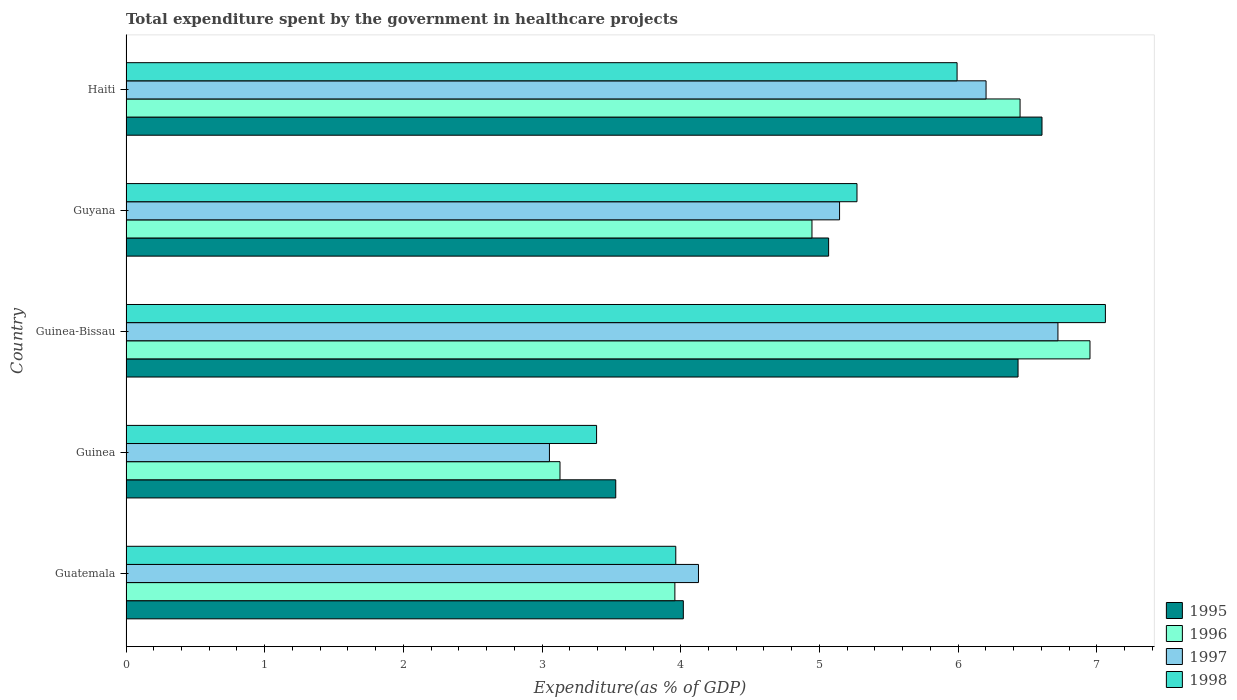How many different coloured bars are there?
Offer a terse response. 4. How many bars are there on the 4th tick from the bottom?
Make the answer very short. 4. What is the label of the 3rd group of bars from the top?
Give a very brief answer. Guinea-Bissau. What is the total expenditure spent by the government in healthcare projects in 1996 in Guinea-Bissau?
Provide a short and direct response. 6.95. Across all countries, what is the maximum total expenditure spent by the government in healthcare projects in 1995?
Ensure brevity in your answer.  6.6. Across all countries, what is the minimum total expenditure spent by the government in healthcare projects in 1997?
Ensure brevity in your answer.  3.05. In which country was the total expenditure spent by the government in healthcare projects in 1998 maximum?
Your answer should be compact. Guinea-Bissau. In which country was the total expenditure spent by the government in healthcare projects in 1995 minimum?
Ensure brevity in your answer.  Guinea. What is the total total expenditure spent by the government in healthcare projects in 1998 in the graph?
Make the answer very short. 25.68. What is the difference between the total expenditure spent by the government in healthcare projects in 1996 in Guyana and that in Haiti?
Make the answer very short. -1.5. What is the difference between the total expenditure spent by the government in healthcare projects in 1996 in Guinea-Bissau and the total expenditure spent by the government in healthcare projects in 1997 in Guatemala?
Give a very brief answer. 2.82. What is the average total expenditure spent by the government in healthcare projects in 1995 per country?
Your answer should be compact. 5.13. What is the difference between the total expenditure spent by the government in healthcare projects in 1995 and total expenditure spent by the government in healthcare projects in 1997 in Guinea-Bissau?
Keep it short and to the point. -0.29. In how many countries, is the total expenditure spent by the government in healthcare projects in 1997 greater than 0.2 %?
Ensure brevity in your answer.  5. What is the ratio of the total expenditure spent by the government in healthcare projects in 1996 in Guatemala to that in Guyana?
Your response must be concise. 0.8. Is the total expenditure spent by the government in healthcare projects in 1995 in Guinea-Bissau less than that in Guyana?
Offer a terse response. No. Is the difference between the total expenditure spent by the government in healthcare projects in 1995 in Guinea and Haiti greater than the difference between the total expenditure spent by the government in healthcare projects in 1997 in Guinea and Haiti?
Your answer should be very brief. Yes. What is the difference between the highest and the second highest total expenditure spent by the government in healthcare projects in 1997?
Give a very brief answer. 0.52. What is the difference between the highest and the lowest total expenditure spent by the government in healthcare projects in 1996?
Your answer should be compact. 3.82. In how many countries, is the total expenditure spent by the government in healthcare projects in 1997 greater than the average total expenditure spent by the government in healthcare projects in 1997 taken over all countries?
Your response must be concise. 3. Is the sum of the total expenditure spent by the government in healthcare projects in 1995 in Guatemala and Guinea-Bissau greater than the maximum total expenditure spent by the government in healthcare projects in 1997 across all countries?
Provide a short and direct response. Yes. What does the 2nd bar from the top in Guinea-Bissau represents?
Provide a succinct answer. 1997. What does the 1st bar from the bottom in Guinea represents?
Provide a succinct answer. 1995. Is it the case that in every country, the sum of the total expenditure spent by the government in healthcare projects in 1996 and total expenditure spent by the government in healthcare projects in 1997 is greater than the total expenditure spent by the government in healthcare projects in 1998?
Your response must be concise. Yes. What is the difference between two consecutive major ticks on the X-axis?
Provide a succinct answer. 1. Are the values on the major ticks of X-axis written in scientific E-notation?
Ensure brevity in your answer.  No. Does the graph contain any zero values?
Your answer should be compact. No. How are the legend labels stacked?
Offer a terse response. Vertical. What is the title of the graph?
Give a very brief answer. Total expenditure spent by the government in healthcare projects. Does "2007" appear as one of the legend labels in the graph?
Keep it short and to the point. No. What is the label or title of the X-axis?
Keep it short and to the point. Expenditure(as % of GDP). What is the Expenditure(as % of GDP) of 1995 in Guatemala?
Your answer should be compact. 4.02. What is the Expenditure(as % of GDP) of 1996 in Guatemala?
Ensure brevity in your answer.  3.96. What is the Expenditure(as % of GDP) of 1997 in Guatemala?
Your answer should be compact. 4.13. What is the Expenditure(as % of GDP) in 1998 in Guatemala?
Give a very brief answer. 3.96. What is the Expenditure(as % of GDP) of 1995 in Guinea?
Ensure brevity in your answer.  3.53. What is the Expenditure(as % of GDP) in 1996 in Guinea?
Your response must be concise. 3.13. What is the Expenditure(as % of GDP) of 1997 in Guinea?
Provide a short and direct response. 3.05. What is the Expenditure(as % of GDP) in 1998 in Guinea?
Provide a succinct answer. 3.39. What is the Expenditure(as % of GDP) in 1995 in Guinea-Bissau?
Provide a short and direct response. 6.43. What is the Expenditure(as % of GDP) of 1996 in Guinea-Bissau?
Provide a short and direct response. 6.95. What is the Expenditure(as % of GDP) of 1997 in Guinea-Bissau?
Give a very brief answer. 6.72. What is the Expenditure(as % of GDP) in 1998 in Guinea-Bissau?
Your answer should be very brief. 7.06. What is the Expenditure(as % of GDP) in 1995 in Guyana?
Offer a very short reply. 5.07. What is the Expenditure(as % of GDP) of 1996 in Guyana?
Ensure brevity in your answer.  4.95. What is the Expenditure(as % of GDP) in 1997 in Guyana?
Ensure brevity in your answer.  5.15. What is the Expenditure(as % of GDP) of 1998 in Guyana?
Keep it short and to the point. 5.27. What is the Expenditure(as % of GDP) in 1995 in Haiti?
Provide a succinct answer. 6.6. What is the Expenditure(as % of GDP) of 1996 in Haiti?
Provide a succinct answer. 6.45. What is the Expenditure(as % of GDP) of 1997 in Haiti?
Your answer should be very brief. 6.2. What is the Expenditure(as % of GDP) in 1998 in Haiti?
Your answer should be compact. 5.99. Across all countries, what is the maximum Expenditure(as % of GDP) of 1995?
Your response must be concise. 6.6. Across all countries, what is the maximum Expenditure(as % of GDP) of 1996?
Make the answer very short. 6.95. Across all countries, what is the maximum Expenditure(as % of GDP) of 1997?
Offer a terse response. 6.72. Across all countries, what is the maximum Expenditure(as % of GDP) of 1998?
Your answer should be very brief. 7.06. Across all countries, what is the minimum Expenditure(as % of GDP) of 1995?
Your answer should be very brief. 3.53. Across all countries, what is the minimum Expenditure(as % of GDP) of 1996?
Your answer should be compact. 3.13. Across all countries, what is the minimum Expenditure(as % of GDP) of 1997?
Offer a terse response. 3.05. Across all countries, what is the minimum Expenditure(as % of GDP) of 1998?
Your answer should be compact. 3.39. What is the total Expenditure(as % of GDP) in 1995 in the graph?
Ensure brevity in your answer.  25.65. What is the total Expenditure(as % of GDP) of 1996 in the graph?
Offer a very short reply. 25.43. What is the total Expenditure(as % of GDP) in 1997 in the graph?
Your response must be concise. 25.25. What is the total Expenditure(as % of GDP) of 1998 in the graph?
Your answer should be very brief. 25.68. What is the difference between the Expenditure(as % of GDP) of 1995 in Guatemala and that in Guinea?
Ensure brevity in your answer.  0.49. What is the difference between the Expenditure(as % of GDP) of 1996 in Guatemala and that in Guinea?
Keep it short and to the point. 0.83. What is the difference between the Expenditure(as % of GDP) in 1997 in Guatemala and that in Guinea?
Your response must be concise. 1.07. What is the difference between the Expenditure(as % of GDP) of 1998 in Guatemala and that in Guinea?
Make the answer very short. 0.57. What is the difference between the Expenditure(as % of GDP) of 1995 in Guatemala and that in Guinea-Bissau?
Offer a very short reply. -2.41. What is the difference between the Expenditure(as % of GDP) of 1996 in Guatemala and that in Guinea-Bissau?
Ensure brevity in your answer.  -2.99. What is the difference between the Expenditure(as % of GDP) in 1997 in Guatemala and that in Guinea-Bissau?
Provide a succinct answer. -2.59. What is the difference between the Expenditure(as % of GDP) in 1998 in Guatemala and that in Guinea-Bissau?
Offer a very short reply. -3.1. What is the difference between the Expenditure(as % of GDP) of 1995 in Guatemala and that in Guyana?
Ensure brevity in your answer.  -1.05. What is the difference between the Expenditure(as % of GDP) in 1996 in Guatemala and that in Guyana?
Your answer should be very brief. -0.99. What is the difference between the Expenditure(as % of GDP) in 1997 in Guatemala and that in Guyana?
Keep it short and to the point. -1.02. What is the difference between the Expenditure(as % of GDP) in 1998 in Guatemala and that in Guyana?
Your answer should be very brief. -1.31. What is the difference between the Expenditure(as % of GDP) in 1995 in Guatemala and that in Haiti?
Keep it short and to the point. -2.59. What is the difference between the Expenditure(as % of GDP) of 1996 in Guatemala and that in Haiti?
Keep it short and to the point. -2.49. What is the difference between the Expenditure(as % of GDP) of 1997 in Guatemala and that in Haiti?
Ensure brevity in your answer.  -2.07. What is the difference between the Expenditure(as % of GDP) in 1998 in Guatemala and that in Haiti?
Keep it short and to the point. -2.03. What is the difference between the Expenditure(as % of GDP) of 1995 in Guinea and that in Guinea-Bissau?
Your answer should be compact. -2.9. What is the difference between the Expenditure(as % of GDP) in 1996 in Guinea and that in Guinea-Bissau?
Make the answer very short. -3.82. What is the difference between the Expenditure(as % of GDP) of 1997 in Guinea and that in Guinea-Bissau?
Your answer should be compact. -3.67. What is the difference between the Expenditure(as % of GDP) of 1998 in Guinea and that in Guinea-Bissau?
Provide a short and direct response. -3.67. What is the difference between the Expenditure(as % of GDP) in 1995 in Guinea and that in Guyana?
Make the answer very short. -1.53. What is the difference between the Expenditure(as % of GDP) in 1996 in Guinea and that in Guyana?
Your answer should be very brief. -1.82. What is the difference between the Expenditure(as % of GDP) of 1997 in Guinea and that in Guyana?
Offer a very short reply. -2.09. What is the difference between the Expenditure(as % of GDP) of 1998 in Guinea and that in Guyana?
Give a very brief answer. -1.88. What is the difference between the Expenditure(as % of GDP) in 1995 in Guinea and that in Haiti?
Provide a short and direct response. -3.07. What is the difference between the Expenditure(as % of GDP) in 1996 in Guinea and that in Haiti?
Make the answer very short. -3.32. What is the difference between the Expenditure(as % of GDP) of 1997 in Guinea and that in Haiti?
Provide a short and direct response. -3.15. What is the difference between the Expenditure(as % of GDP) in 1998 in Guinea and that in Haiti?
Your answer should be compact. -2.6. What is the difference between the Expenditure(as % of GDP) in 1995 in Guinea-Bissau and that in Guyana?
Ensure brevity in your answer.  1.37. What is the difference between the Expenditure(as % of GDP) in 1996 in Guinea-Bissau and that in Guyana?
Make the answer very short. 2. What is the difference between the Expenditure(as % of GDP) of 1997 in Guinea-Bissau and that in Guyana?
Keep it short and to the point. 1.57. What is the difference between the Expenditure(as % of GDP) in 1998 in Guinea-Bissau and that in Guyana?
Give a very brief answer. 1.79. What is the difference between the Expenditure(as % of GDP) in 1995 in Guinea-Bissau and that in Haiti?
Your answer should be compact. -0.17. What is the difference between the Expenditure(as % of GDP) in 1996 in Guinea-Bissau and that in Haiti?
Make the answer very short. 0.5. What is the difference between the Expenditure(as % of GDP) in 1997 in Guinea-Bissau and that in Haiti?
Your answer should be compact. 0.52. What is the difference between the Expenditure(as % of GDP) of 1998 in Guinea-Bissau and that in Haiti?
Provide a short and direct response. 1.07. What is the difference between the Expenditure(as % of GDP) in 1995 in Guyana and that in Haiti?
Give a very brief answer. -1.54. What is the difference between the Expenditure(as % of GDP) in 1996 in Guyana and that in Haiti?
Your answer should be compact. -1.5. What is the difference between the Expenditure(as % of GDP) of 1997 in Guyana and that in Haiti?
Offer a terse response. -1.06. What is the difference between the Expenditure(as % of GDP) of 1998 in Guyana and that in Haiti?
Make the answer very short. -0.72. What is the difference between the Expenditure(as % of GDP) of 1995 in Guatemala and the Expenditure(as % of GDP) of 1996 in Guinea?
Provide a short and direct response. 0.89. What is the difference between the Expenditure(as % of GDP) in 1995 in Guatemala and the Expenditure(as % of GDP) in 1997 in Guinea?
Your answer should be very brief. 0.97. What is the difference between the Expenditure(as % of GDP) in 1995 in Guatemala and the Expenditure(as % of GDP) in 1998 in Guinea?
Provide a short and direct response. 0.63. What is the difference between the Expenditure(as % of GDP) of 1996 in Guatemala and the Expenditure(as % of GDP) of 1997 in Guinea?
Keep it short and to the point. 0.9. What is the difference between the Expenditure(as % of GDP) of 1996 in Guatemala and the Expenditure(as % of GDP) of 1998 in Guinea?
Your response must be concise. 0.56. What is the difference between the Expenditure(as % of GDP) in 1997 in Guatemala and the Expenditure(as % of GDP) in 1998 in Guinea?
Your answer should be compact. 0.73. What is the difference between the Expenditure(as % of GDP) in 1995 in Guatemala and the Expenditure(as % of GDP) in 1996 in Guinea-Bissau?
Your response must be concise. -2.93. What is the difference between the Expenditure(as % of GDP) in 1995 in Guatemala and the Expenditure(as % of GDP) in 1997 in Guinea-Bissau?
Offer a terse response. -2.7. What is the difference between the Expenditure(as % of GDP) in 1995 in Guatemala and the Expenditure(as % of GDP) in 1998 in Guinea-Bissau?
Your answer should be compact. -3.04. What is the difference between the Expenditure(as % of GDP) of 1996 in Guatemala and the Expenditure(as % of GDP) of 1997 in Guinea-Bissau?
Give a very brief answer. -2.76. What is the difference between the Expenditure(as % of GDP) of 1996 in Guatemala and the Expenditure(as % of GDP) of 1998 in Guinea-Bissau?
Your answer should be compact. -3.1. What is the difference between the Expenditure(as % of GDP) in 1997 in Guatemala and the Expenditure(as % of GDP) in 1998 in Guinea-Bissau?
Your answer should be compact. -2.93. What is the difference between the Expenditure(as % of GDP) in 1995 in Guatemala and the Expenditure(as % of GDP) in 1996 in Guyana?
Your answer should be compact. -0.93. What is the difference between the Expenditure(as % of GDP) of 1995 in Guatemala and the Expenditure(as % of GDP) of 1997 in Guyana?
Offer a very short reply. -1.13. What is the difference between the Expenditure(as % of GDP) of 1995 in Guatemala and the Expenditure(as % of GDP) of 1998 in Guyana?
Your answer should be very brief. -1.25. What is the difference between the Expenditure(as % of GDP) in 1996 in Guatemala and the Expenditure(as % of GDP) in 1997 in Guyana?
Make the answer very short. -1.19. What is the difference between the Expenditure(as % of GDP) in 1996 in Guatemala and the Expenditure(as % of GDP) in 1998 in Guyana?
Ensure brevity in your answer.  -1.31. What is the difference between the Expenditure(as % of GDP) in 1997 in Guatemala and the Expenditure(as % of GDP) in 1998 in Guyana?
Make the answer very short. -1.14. What is the difference between the Expenditure(as % of GDP) in 1995 in Guatemala and the Expenditure(as % of GDP) in 1996 in Haiti?
Offer a very short reply. -2.43. What is the difference between the Expenditure(as % of GDP) of 1995 in Guatemala and the Expenditure(as % of GDP) of 1997 in Haiti?
Your answer should be compact. -2.18. What is the difference between the Expenditure(as % of GDP) in 1995 in Guatemala and the Expenditure(as % of GDP) in 1998 in Haiti?
Offer a terse response. -1.97. What is the difference between the Expenditure(as % of GDP) of 1996 in Guatemala and the Expenditure(as % of GDP) of 1997 in Haiti?
Your answer should be compact. -2.24. What is the difference between the Expenditure(as % of GDP) in 1996 in Guatemala and the Expenditure(as % of GDP) in 1998 in Haiti?
Keep it short and to the point. -2.03. What is the difference between the Expenditure(as % of GDP) of 1997 in Guatemala and the Expenditure(as % of GDP) of 1998 in Haiti?
Offer a terse response. -1.86. What is the difference between the Expenditure(as % of GDP) in 1995 in Guinea and the Expenditure(as % of GDP) in 1996 in Guinea-Bissau?
Keep it short and to the point. -3.42. What is the difference between the Expenditure(as % of GDP) of 1995 in Guinea and the Expenditure(as % of GDP) of 1997 in Guinea-Bissau?
Make the answer very short. -3.19. What is the difference between the Expenditure(as % of GDP) of 1995 in Guinea and the Expenditure(as % of GDP) of 1998 in Guinea-Bissau?
Give a very brief answer. -3.53. What is the difference between the Expenditure(as % of GDP) of 1996 in Guinea and the Expenditure(as % of GDP) of 1997 in Guinea-Bissau?
Provide a short and direct response. -3.59. What is the difference between the Expenditure(as % of GDP) of 1996 in Guinea and the Expenditure(as % of GDP) of 1998 in Guinea-Bissau?
Your response must be concise. -3.93. What is the difference between the Expenditure(as % of GDP) of 1997 in Guinea and the Expenditure(as % of GDP) of 1998 in Guinea-Bissau?
Ensure brevity in your answer.  -4.01. What is the difference between the Expenditure(as % of GDP) in 1995 in Guinea and the Expenditure(as % of GDP) in 1996 in Guyana?
Ensure brevity in your answer.  -1.41. What is the difference between the Expenditure(as % of GDP) of 1995 in Guinea and the Expenditure(as % of GDP) of 1997 in Guyana?
Keep it short and to the point. -1.61. What is the difference between the Expenditure(as % of GDP) in 1995 in Guinea and the Expenditure(as % of GDP) in 1998 in Guyana?
Keep it short and to the point. -1.74. What is the difference between the Expenditure(as % of GDP) in 1996 in Guinea and the Expenditure(as % of GDP) in 1997 in Guyana?
Give a very brief answer. -2.02. What is the difference between the Expenditure(as % of GDP) of 1996 in Guinea and the Expenditure(as % of GDP) of 1998 in Guyana?
Provide a succinct answer. -2.14. What is the difference between the Expenditure(as % of GDP) of 1997 in Guinea and the Expenditure(as % of GDP) of 1998 in Guyana?
Your answer should be very brief. -2.22. What is the difference between the Expenditure(as % of GDP) of 1995 in Guinea and the Expenditure(as % of GDP) of 1996 in Haiti?
Your answer should be compact. -2.92. What is the difference between the Expenditure(as % of GDP) in 1995 in Guinea and the Expenditure(as % of GDP) in 1997 in Haiti?
Provide a short and direct response. -2.67. What is the difference between the Expenditure(as % of GDP) of 1995 in Guinea and the Expenditure(as % of GDP) of 1998 in Haiti?
Your response must be concise. -2.46. What is the difference between the Expenditure(as % of GDP) in 1996 in Guinea and the Expenditure(as % of GDP) in 1997 in Haiti?
Your answer should be compact. -3.07. What is the difference between the Expenditure(as % of GDP) in 1996 in Guinea and the Expenditure(as % of GDP) in 1998 in Haiti?
Your answer should be compact. -2.86. What is the difference between the Expenditure(as % of GDP) of 1997 in Guinea and the Expenditure(as % of GDP) of 1998 in Haiti?
Provide a succinct answer. -2.94. What is the difference between the Expenditure(as % of GDP) of 1995 in Guinea-Bissau and the Expenditure(as % of GDP) of 1996 in Guyana?
Your answer should be compact. 1.49. What is the difference between the Expenditure(as % of GDP) in 1995 in Guinea-Bissau and the Expenditure(as % of GDP) in 1997 in Guyana?
Give a very brief answer. 1.29. What is the difference between the Expenditure(as % of GDP) of 1995 in Guinea-Bissau and the Expenditure(as % of GDP) of 1998 in Guyana?
Offer a very short reply. 1.16. What is the difference between the Expenditure(as % of GDP) of 1996 in Guinea-Bissau and the Expenditure(as % of GDP) of 1997 in Guyana?
Ensure brevity in your answer.  1.81. What is the difference between the Expenditure(as % of GDP) of 1996 in Guinea-Bissau and the Expenditure(as % of GDP) of 1998 in Guyana?
Your answer should be compact. 1.68. What is the difference between the Expenditure(as % of GDP) of 1997 in Guinea-Bissau and the Expenditure(as % of GDP) of 1998 in Guyana?
Give a very brief answer. 1.45. What is the difference between the Expenditure(as % of GDP) in 1995 in Guinea-Bissau and the Expenditure(as % of GDP) in 1996 in Haiti?
Offer a terse response. -0.01. What is the difference between the Expenditure(as % of GDP) of 1995 in Guinea-Bissau and the Expenditure(as % of GDP) of 1997 in Haiti?
Offer a very short reply. 0.23. What is the difference between the Expenditure(as % of GDP) of 1995 in Guinea-Bissau and the Expenditure(as % of GDP) of 1998 in Haiti?
Provide a short and direct response. 0.44. What is the difference between the Expenditure(as % of GDP) in 1996 in Guinea-Bissau and the Expenditure(as % of GDP) in 1997 in Haiti?
Your answer should be very brief. 0.75. What is the difference between the Expenditure(as % of GDP) in 1996 in Guinea-Bissau and the Expenditure(as % of GDP) in 1998 in Haiti?
Provide a short and direct response. 0.96. What is the difference between the Expenditure(as % of GDP) of 1997 in Guinea-Bissau and the Expenditure(as % of GDP) of 1998 in Haiti?
Offer a terse response. 0.73. What is the difference between the Expenditure(as % of GDP) of 1995 in Guyana and the Expenditure(as % of GDP) of 1996 in Haiti?
Keep it short and to the point. -1.38. What is the difference between the Expenditure(as % of GDP) of 1995 in Guyana and the Expenditure(as % of GDP) of 1997 in Haiti?
Make the answer very short. -1.14. What is the difference between the Expenditure(as % of GDP) of 1995 in Guyana and the Expenditure(as % of GDP) of 1998 in Haiti?
Your answer should be compact. -0.93. What is the difference between the Expenditure(as % of GDP) in 1996 in Guyana and the Expenditure(as % of GDP) in 1997 in Haiti?
Your response must be concise. -1.26. What is the difference between the Expenditure(as % of GDP) of 1996 in Guyana and the Expenditure(as % of GDP) of 1998 in Haiti?
Your response must be concise. -1.05. What is the difference between the Expenditure(as % of GDP) of 1997 in Guyana and the Expenditure(as % of GDP) of 1998 in Haiti?
Ensure brevity in your answer.  -0.85. What is the average Expenditure(as % of GDP) in 1995 per country?
Provide a succinct answer. 5.13. What is the average Expenditure(as % of GDP) in 1996 per country?
Offer a terse response. 5.09. What is the average Expenditure(as % of GDP) in 1997 per country?
Make the answer very short. 5.05. What is the average Expenditure(as % of GDP) in 1998 per country?
Your answer should be compact. 5.14. What is the difference between the Expenditure(as % of GDP) in 1995 and Expenditure(as % of GDP) in 1996 in Guatemala?
Offer a terse response. 0.06. What is the difference between the Expenditure(as % of GDP) in 1995 and Expenditure(as % of GDP) in 1997 in Guatemala?
Ensure brevity in your answer.  -0.11. What is the difference between the Expenditure(as % of GDP) in 1995 and Expenditure(as % of GDP) in 1998 in Guatemala?
Provide a short and direct response. 0.05. What is the difference between the Expenditure(as % of GDP) in 1996 and Expenditure(as % of GDP) in 1997 in Guatemala?
Offer a terse response. -0.17. What is the difference between the Expenditure(as % of GDP) of 1996 and Expenditure(as % of GDP) of 1998 in Guatemala?
Provide a short and direct response. -0.01. What is the difference between the Expenditure(as % of GDP) of 1997 and Expenditure(as % of GDP) of 1998 in Guatemala?
Offer a very short reply. 0.16. What is the difference between the Expenditure(as % of GDP) of 1995 and Expenditure(as % of GDP) of 1996 in Guinea?
Your answer should be very brief. 0.4. What is the difference between the Expenditure(as % of GDP) of 1995 and Expenditure(as % of GDP) of 1997 in Guinea?
Your answer should be very brief. 0.48. What is the difference between the Expenditure(as % of GDP) in 1995 and Expenditure(as % of GDP) in 1998 in Guinea?
Make the answer very short. 0.14. What is the difference between the Expenditure(as % of GDP) in 1996 and Expenditure(as % of GDP) in 1997 in Guinea?
Ensure brevity in your answer.  0.08. What is the difference between the Expenditure(as % of GDP) in 1996 and Expenditure(as % of GDP) in 1998 in Guinea?
Your answer should be very brief. -0.26. What is the difference between the Expenditure(as % of GDP) of 1997 and Expenditure(as % of GDP) of 1998 in Guinea?
Your answer should be very brief. -0.34. What is the difference between the Expenditure(as % of GDP) in 1995 and Expenditure(as % of GDP) in 1996 in Guinea-Bissau?
Give a very brief answer. -0.52. What is the difference between the Expenditure(as % of GDP) of 1995 and Expenditure(as % of GDP) of 1997 in Guinea-Bissau?
Ensure brevity in your answer.  -0.29. What is the difference between the Expenditure(as % of GDP) of 1995 and Expenditure(as % of GDP) of 1998 in Guinea-Bissau?
Keep it short and to the point. -0.63. What is the difference between the Expenditure(as % of GDP) of 1996 and Expenditure(as % of GDP) of 1997 in Guinea-Bissau?
Provide a short and direct response. 0.23. What is the difference between the Expenditure(as % of GDP) in 1996 and Expenditure(as % of GDP) in 1998 in Guinea-Bissau?
Give a very brief answer. -0.11. What is the difference between the Expenditure(as % of GDP) of 1997 and Expenditure(as % of GDP) of 1998 in Guinea-Bissau?
Offer a very short reply. -0.34. What is the difference between the Expenditure(as % of GDP) of 1995 and Expenditure(as % of GDP) of 1996 in Guyana?
Give a very brief answer. 0.12. What is the difference between the Expenditure(as % of GDP) of 1995 and Expenditure(as % of GDP) of 1997 in Guyana?
Your answer should be very brief. -0.08. What is the difference between the Expenditure(as % of GDP) in 1995 and Expenditure(as % of GDP) in 1998 in Guyana?
Ensure brevity in your answer.  -0.2. What is the difference between the Expenditure(as % of GDP) in 1996 and Expenditure(as % of GDP) in 1997 in Guyana?
Offer a very short reply. -0.2. What is the difference between the Expenditure(as % of GDP) in 1996 and Expenditure(as % of GDP) in 1998 in Guyana?
Make the answer very short. -0.32. What is the difference between the Expenditure(as % of GDP) of 1997 and Expenditure(as % of GDP) of 1998 in Guyana?
Your answer should be compact. -0.13. What is the difference between the Expenditure(as % of GDP) in 1995 and Expenditure(as % of GDP) in 1996 in Haiti?
Your answer should be compact. 0.16. What is the difference between the Expenditure(as % of GDP) in 1995 and Expenditure(as % of GDP) in 1997 in Haiti?
Ensure brevity in your answer.  0.4. What is the difference between the Expenditure(as % of GDP) of 1995 and Expenditure(as % of GDP) of 1998 in Haiti?
Offer a terse response. 0.61. What is the difference between the Expenditure(as % of GDP) in 1996 and Expenditure(as % of GDP) in 1997 in Haiti?
Offer a very short reply. 0.25. What is the difference between the Expenditure(as % of GDP) of 1996 and Expenditure(as % of GDP) of 1998 in Haiti?
Your answer should be compact. 0.45. What is the difference between the Expenditure(as % of GDP) of 1997 and Expenditure(as % of GDP) of 1998 in Haiti?
Offer a terse response. 0.21. What is the ratio of the Expenditure(as % of GDP) in 1995 in Guatemala to that in Guinea?
Ensure brevity in your answer.  1.14. What is the ratio of the Expenditure(as % of GDP) of 1996 in Guatemala to that in Guinea?
Give a very brief answer. 1.26. What is the ratio of the Expenditure(as % of GDP) in 1997 in Guatemala to that in Guinea?
Your response must be concise. 1.35. What is the ratio of the Expenditure(as % of GDP) of 1998 in Guatemala to that in Guinea?
Offer a terse response. 1.17. What is the ratio of the Expenditure(as % of GDP) of 1995 in Guatemala to that in Guinea-Bissau?
Provide a succinct answer. 0.62. What is the ratio of the Expenditure(as % of GDP) of 1996 in Guatemala to that in Guinea-Bissau?
Your answer should be compact. 0.57. What is the ratio of the Expenditure(as % of GDP) of 1997 in Guatemala to that in Guinea-Bissau?
Give a very brief answer. 0.61. What is the ratio of the Expenditure(as % of GDP) in 1998 in Guatemala to that in Guinea-Bissau?
Your answer should be compact. 0.56. What is the ratio of the Expenditure(as % of GDP) of 1995 in Guatemala to that in Guyana?
Your answer should be compact. 0.79. What is the ratio of the Expenditure(as % of GDP) of 1996 in Guatemala to that in Guyana?
Provide a short and direct response. 0.8. What is the ratio of the Expenditure(as % of GDP) of 1997 in Guatemala to that in Guyana?
Offer a very short reply. 0.8. What is the ratio of the Expenditure(as % of GDP) in 1998 in Guatemala to that in Guyana?
Offer a very short reply. 0.75. What is the ratio of the Expenditure(as % of GDP) in 1995 in Guatemala to that in Haiti?
Provide a short and direct response. 0.61. What is the ratio of the Expenditure(as % of GDP) of 1996 in Guatemala to that in Haiti?
Give a very brief answer. 0.61. What is the ratio of the Expenditure(as % of GDP) of 1997 in Guatemala to that in Haiti?
Offer a very short reply. 0.67. What is the ratio of the Expenditure(as % of GDP) in 1998 in Guatemala to that in Haiti?
Offer a very short reply. 0.66. What is the ratio of the Expenditure(as % of GDP) of 1995 in Guinea to that in Guinea-Bissau?
Give a very brief answer. 0.55. What is the ratio of the Expenditure(as % of GDP) in 1996 in Guinea to that in Guinea-Bissau?
Offer a terse response. 0.45. What is the ratio of the Expenditure(as % of GDP) of 1997 in Guinea to that in Guinea-Bissau?
Your response must be concise. 0.45. What is the ratio of the Expenditure(as % of GDP) in 1998 in Guinea to that in Guinea-Bissau?
Offer a very short reply. 0.48. What is the ratio of the Expenditure(as % of GDP) of 1995 in Guinea to that in Guyana?
Keep it short and to the point. 0.7. What is the ratio of the Expenditure(as % of GDP) in 1996 in Guinea to that in Guyana?
Provide a succinct answer. 0.63. What is the ratio of the Expenditure(as % of GDP) of 1997 in Guinea to that in Guyana?
Offer a very short reply. 0.59. What is the ratio of the Expenditure(as % of GDP) in 1998 in Guinea to that in Guyana?
Make the answer very short. 0.64. What is the ratio of the Expenditure(as % of GDP) of 1995 in Guinea to that in Haiti?
Give a very brief answer. 0.53. What is the ratio of the Expenditure(as % of GDP) in 1996 in Guinea to that in Haiti?
Your answer should be compact. 0.49. What is the ratio of the Expenditure(as % of GDP) in 1997 in Guinea to that in Haiti?
Your response must be concise. 0.49. What is the ratio of the Expenditure(as % of GDP) in 1998 in Guinea to that in Haiti?
Ensure brevity in your answer.  0.57. What is the ratio of the Expenditure(as % of GDP) in 1995 in Guinea-Bissau to that in Guyana?
Your response must be concise. 1.27. What is the ratio of the Expenditure(as % of GDP) in 1996 in Guinea-Bissau to that in Guyana?
Your answer should be very brief. 1.41. What is the ratio of the Expenditure(as % of GDP) in 1997 in Guinea-Bissau to that in Guyana?
Provide a succinct answer. 1.31. What is the ratio of the Expenditure(as % of GDP) of 1998 in Guinea-Bissau to that in Guyana?
Offer a very short reply. 1.34. What is the ratio of the Expenditure(as % of GDP) in 1995 in Guinea-Bissau to that in Haiti?
Your answer should be very brief. 0.97. What is the ratio of the Expenditure(as % of GDP) in 1996 in Guinea-Bissau to that in Haiti?
Give a very brief answer. 1.08. What is the ratio of the Expenditure(as % of GDP) in 1997 in Guinea-Bissau to that in Haiti?
Give a very brief answer. 1.08. What is the ratio of the Expenditure(as % of GDP) of 1998 in Guinea-Bissau to that in Haiti?
Offer a terse response. 1.18. What is the ratio of the Expenditure(as % of GDP) in 1995 in Guyana to that in Haiti?
Offer a very short reply. 0.77. What is the ratio of the Expenditure(as % of GDP) in 1996 in Guyana to that in Haiti?
Give a very brief answer. 0.77. What is the ratio of the Expenditure(as % of GDP) of 1997 in Guyana to that in Haiti?
Give a very brief answer. 0.83. What is the ratio of the Expenditure(as % of GDP) of 1998 in Guyana to that in Haiti?
Your answer should be very brief. 0.88. What is the difference between the highest and the second highest Expenditure(as % of GDP) in 1995?
Provide a short and direct response. 0.17. What is the difference between the highest and the second highest Expenditure(as % of GDP) in 1996?
Keep it short and to the point. 0.5. What is the difference between the highest and the second highest Expenditure(as % of GDP) of 1997?
Give a very brief answer. 0.52. What is the difference between the highest and the second highest Expenditure(as % of GDP) of 1998?
Your answer should be compact. 1.07. What is the difference between the highest and the lowest Expenditure(as % of GDP) of 1995?
Give a very brief answer. 3.07. What is the difference between the highest and the lowest Expenditure(as % of GDP) in 1996?
Ensure brevity in your answer.  3.82. What is the difference between the highest and the lowest Expenditure(as % of GDP) in 1997?
Your answer should be very brief. 3.67. What is the difference between the highest and the lowest Expenditure(as % of GDP) in 1998?
Provide a succinct answer. 3.67. 